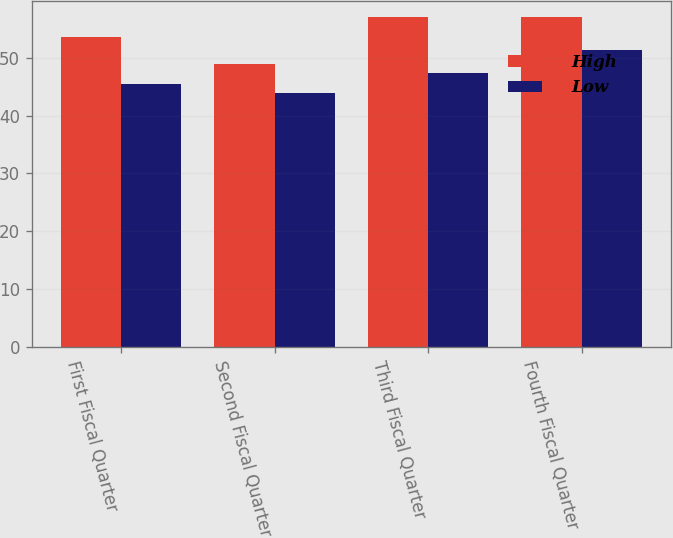Convert chart to OTSL. <chart><loc_0><loc_0><loc_500><loc_500><stacked_bar_chart><ecel><fcel>First Fiscal Quarter<fcel>Second Fiscal Quarter<fcel>Third Fiscal Quarter<fcel>Fourth Fiscal Quarter<nl><fcel>High<fcel>53.59<fcel>48.9<fcel>57.02<fcel>56.98<nl><fcel>Low<fcel>45.49<fcel>43.97<fcel>47.37<fcel>51.3<nl></chart> 